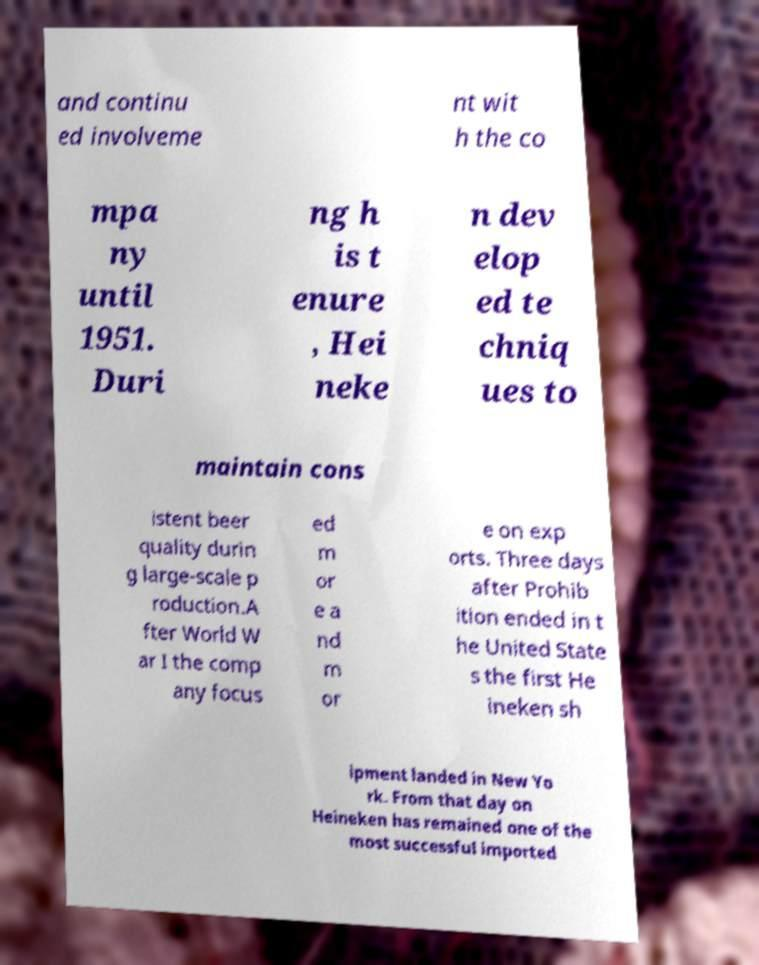Could you assist in decoding the text presented in this image and type it out clearly? and continu ed involveme nt wit h the co mpa ny until 1951. Duri ng h is t enure , Hei neke n dev elop ed te chniq ues to maintain cons istent beer quality durin g large-scale p roduction.A fter World W ar I the comp any focus ed m or e a nd m or e on exp orts. Three days after Prohib ition ended in t he United State s the first He ineken sh ipment landed in New Yo rk. From that day on Heineken has remained one of the most successful imported 